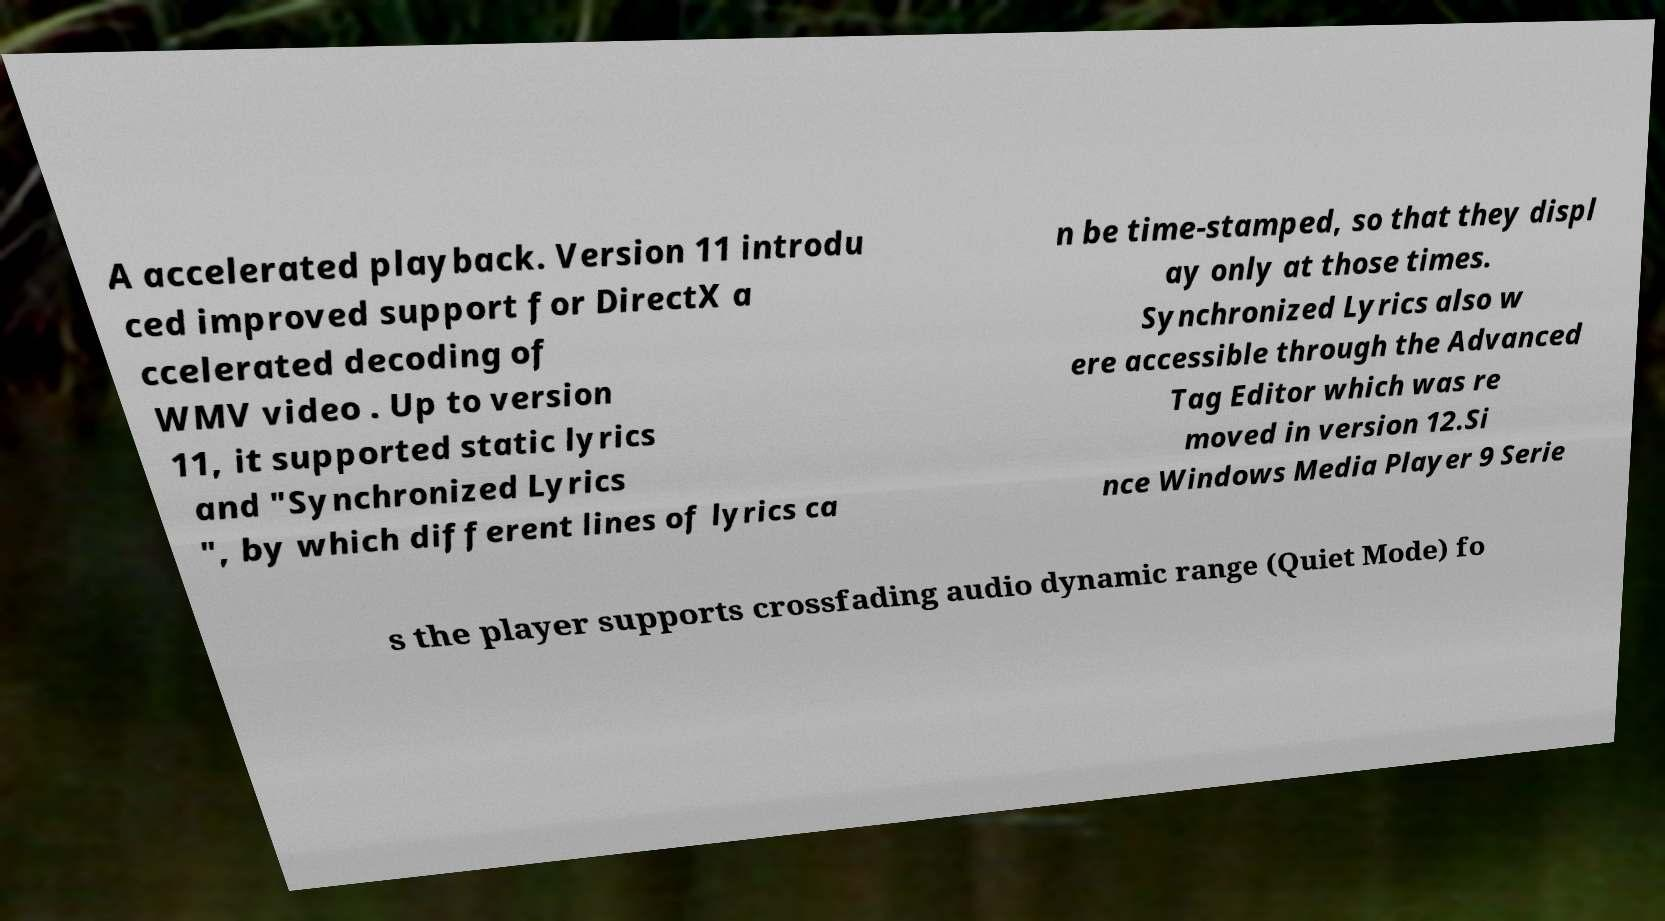Could you assist in decoding the text presented in this image and type it out clearly? A accelerated playback. Version 11 introdu ced improved support for DirectX a ccelerated decoding of WMV video . Up to version 11, it supported static lyrics and "Synchronized Lyrics ", by which different lines of lyrics ca n be time-stamped, so that they displ ay only at those times. Synchronized Lyrics also w ere accessible through the Advanced Tag Editor which was re moved in version 12.Si nce Windows Media Player 9 Serie s the player supports crossfading audio dynamic range (Quiet Mode) fo 